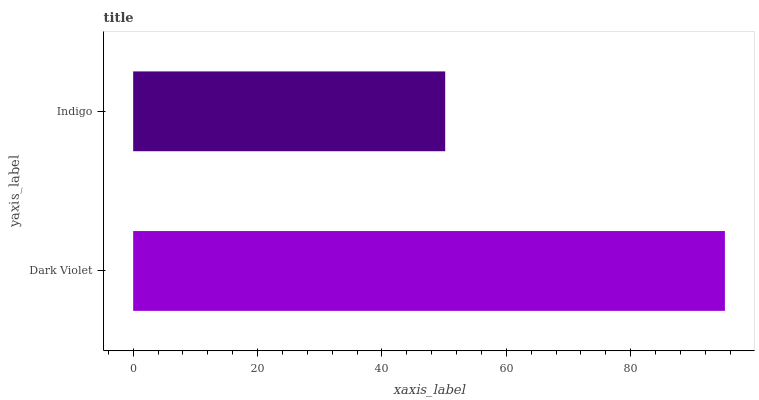Is Indigo the minimum?
Answer yes or no. Yes. Is Dark Violet the maximum?
Answer yes or no. Yes. Is Indigo the maximum?
Answer yes or no. No. Is Dark Violet greater than Indigo?
Answer yes or no. Yes. Is Indigo less than Dark Violet?
Answer yes or no. Yes. Is Indigo greater than Dark Violet?
Answer yes or no. No. Is Dark Violet less than Indigo?
Answer yes or no. No. Is Dark Violet the high median?
Answer yes or no. Yes. Is Indigo the low median?
Answer yes or no. Yes. Is Indigo the high median?
Answer yes or no. No. Is Dark Violet the low median?
Answer yes or no. No. 